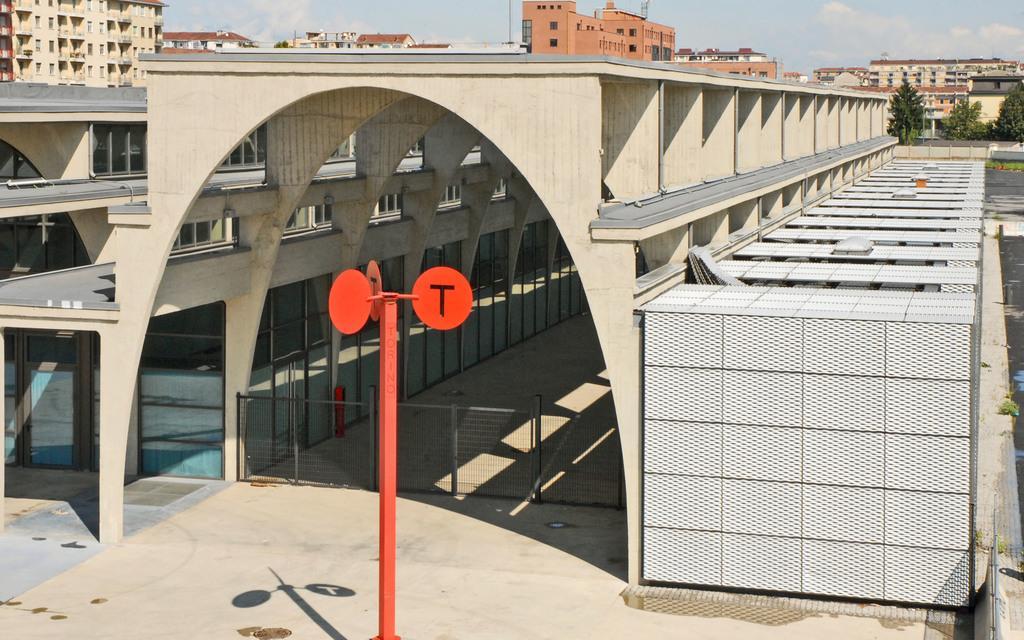How would you summarize this image in a sentence or two? In this image, there are buildings, boards to a pole and there is a gate. On the right side of the image, I can see the trees. In the background there is the sky. 